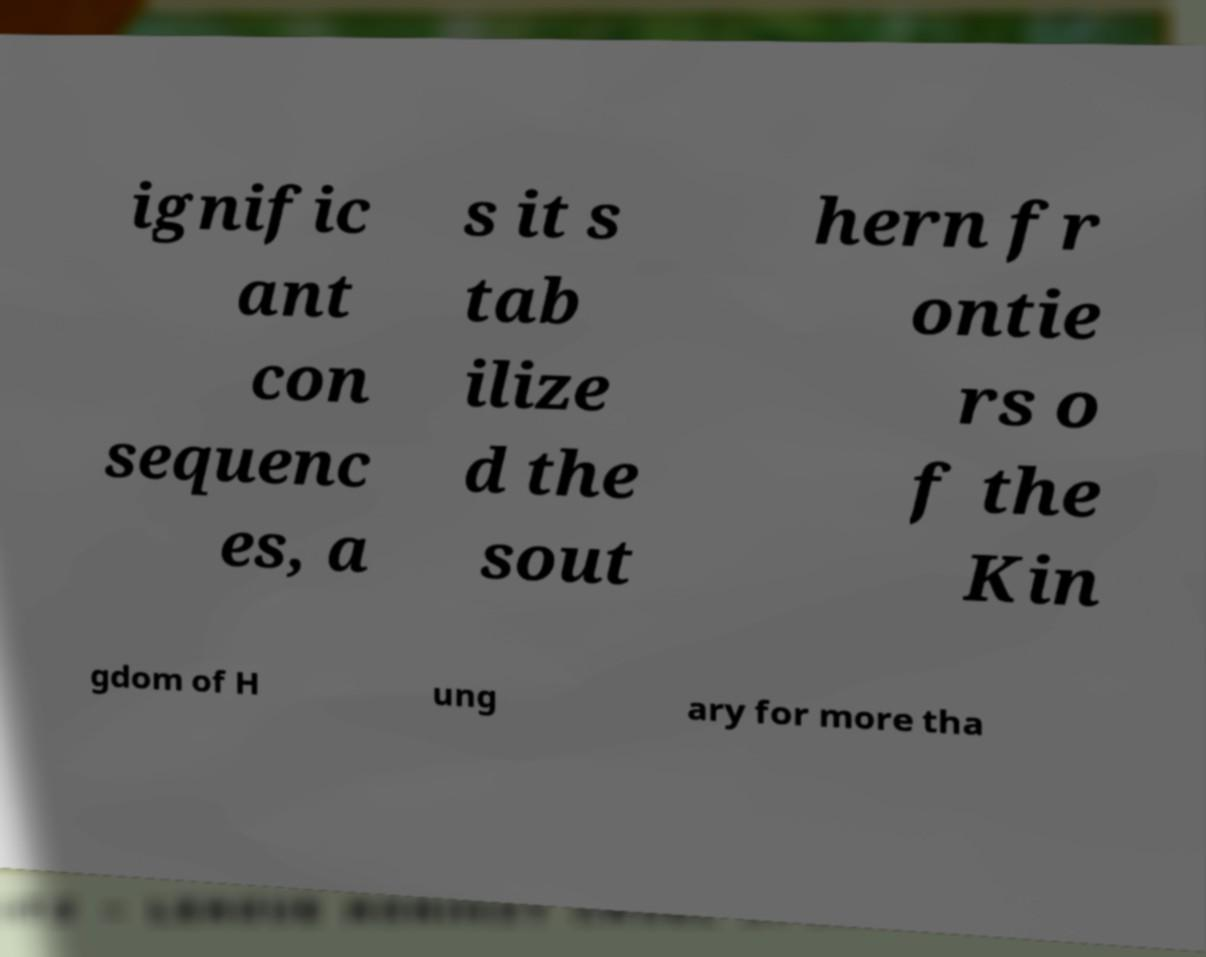Please identify and transcribe the text found in this image. ignific ant con sequenc es, a s it s tab ilize d the sout hern fr ontie rs o f the Kin gdom of H ung ary for more tha 